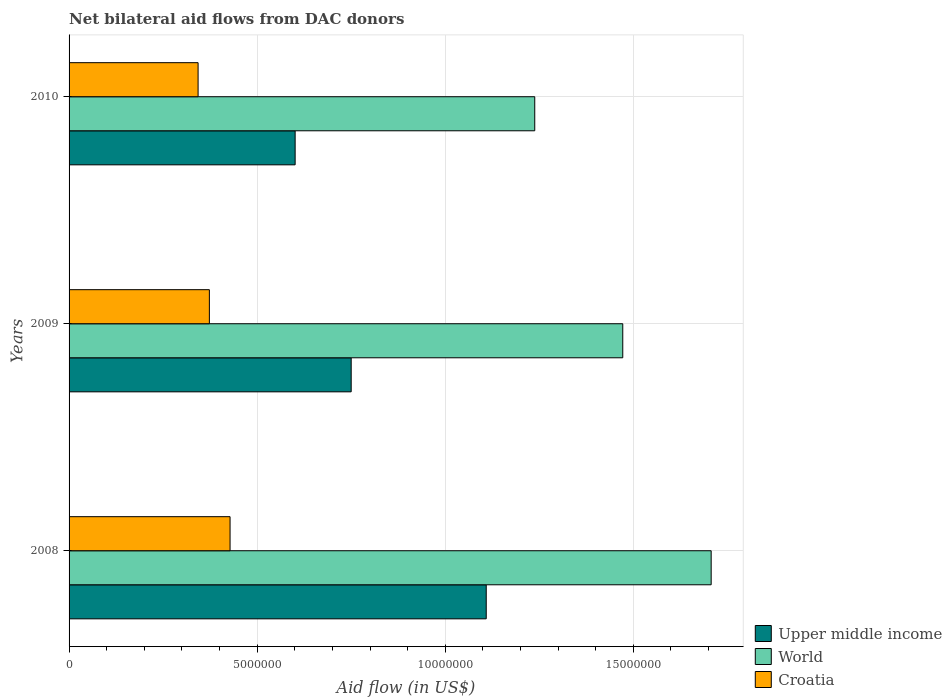Are the number of bars on each tick of the Y-axis equal?
Give a very brief answer. Yes. What is the label of the 2nd group of bars from the top?
Give a very brief answer. 2009. In how many cases, is the number of bars for a given year not equal to the number of legend labels?
Your response must be concise. 0. What is the net bilateral aid flow in Croatia in 2008?
Make the answer very short. 4.28e+06. Across all years, what is the maximum net bilateral aid flow in Croatia?
Offer a very short reply. 4.28e+06. Across all years, what is the minimum net bilateral aid flow in Croatia?
Offer a very short reply. 3.43e+06. In which year was the net bilateral aid flow in Croatia minimum?
Your answer should be very brief. 2010. What is the total net bilateral aid flow in World in the graph?
Provide a succinct answer. 4.42e+07. What is the difference between the net bilateral aid flow in Upper middle income in 2009 and that in 2010?
Your answer should be compact. 1.49e+06. What is the difference between the net bilateral aid flow in Upper middle income in 2009 and the net bilateral aid flow in Croatia in 2008?
Keep it short and to the point. 3.22e+06. What is the average net bilateral aid flow in World per year?
Your answer should be very brief. 1.47e+07. In the year 2010, what is the difference between the net bilateral aid flow in Upper middle income and net bilateral aid flow in Croatia?
Keep it short and to the point. 2.58e+06. In how many years, is the net bilateral aid flow in Upper middle income greater than 4000000 US$?
Your answer should be very brief. 3. What is the ratio of the net bilateral aid flow in Croatia in 2008 to that in 2009?
Make the answer very short. 1.15. Is the difference between the net bilateral aid flow in Upper middle income in 2008 and 2009 greater than the difference between the net bilateral aid flow in Croatia in 2008 and 2009?
Give a very brief answer. Yes. What is the difference between the highest and the second highest net bilateral aid flow in Croatia?
Your answer should be very brief. 5.50e+05. What is the difference between the highest and the lowest net bilateral aid flow in Upper middle income?
Provide a short and direct response. 5.08e+06. In how many years, is the net bilateral aid flow in Croatia greater than the average net bilateral aid flow in Croatia taken over all years?
Make the answer very short. 1. Is the sum of the net bilateral aid flow in Croatia in 2009 and 2010 greater than the maximum net bilateral aid flow in World across all years?
Provide a short and direct response. No. What does the 1st bar from the top in 2008 represents?
Make the answer very short. Croatia. Is it the case that in every year, the sum of the net bilateral aid flow in Upper middle income and net bilateral aid flow in World is greater than the net bilateral aid flow in Croatia?
Give a very brief answer. Yes. Are all the bars in the graph horizontal?
Your response must be concise. Yes. How many years are there in the graph?
Keep it short and to the point. 3. What is the difference between two consecutive major ticks on the X-axis?
Ensure brevity in your answer.  5.00e+06. Does the graph contain any zero values?
Your answer should be compact. No. Does the graph contain grids?
Provide a short and direct response. Yes. Where does the legend appear in the graph?
Provide a short and direct response. Bottom right. How are the legend labels stacked?
Provide a short and direct response. Vertical. What is the title of the graph?
Your answer should be compact. Net bilateral aid flows from DAC donors. Does "OECD members" appear as one of the legend labels in the graph?
Offer a terse response. No. What is the label or title of the X-axis?
Give a very brief answer. Aid flow (in US$). What is the Aid flow (in US$) of Upper middle income in 2008?
Keep it short and to the point. 1.11e+07. What is the Aid flow (in US$) in World in 2008?
Keep it short and to the point. 1.71e+07. What is the Aid flow (in US$) of Croatia in 2008?
Your answer should be compact. 4.28e+06. What is the Aid flow (in US$) in Upper middle income in 2009?
Offer a terse response. 7.50e+06. What is the Aid flow (in US$) in World in 2009?
Keep it short and to the point. 1.47e+07. What is the Aid flow (in US$) of Croatia in 2009?
Make the answer very short. 3.73e+06. What is the Aid flow (in US$) of Upper middle income in 2010?
Provide a short and direct response. 6.01e+06. What is the Aid flow (in US$) in World in 2010?
Your answer should be very brief. 1.24e+07. What is the Aid flow (in US$) in Croatia in 2010?
Provide a succinct answer. 3.43e+06. Across all years, what is the maximum Aid flow (in US$) in Upper middle income?
Offer a very short reply. 1.11e+07. Across all years, what is the maximum Aid flow (in US$) of World?
Keep it short and to the point. 1.71e+07. Across all years, what is the maximum Aid flow (in US$) of Croatia?
Provide a short and direct response. 4.28e+06. Across all years, what is the minimum Aid flow (in US$) of Upper middle income?
Your answer should be very brief. 6.01e+06. Across all years, what is the minimum Aid flow (in US$) of World?
Provide a succinct answer. 1.24e+07. Across all years, what is the minimum Aid flow (in US$) in Croatia?
Your answer should be compact. 3.43e+06. What is the total Aid flow (in US$) in Upper middle income in the graph?
Offer a very short reply. 2.46e+07. What is the total Aid flow (in US$) in World in the graph?
Give a very brief answer. 4.42e+07. What is the total Aid flow (in US$) of Croatia in the graph?
Your response must be concise. 1.14e+07. What is the difference between the Aid flow (in US$) of Upper middle income in 2008 and that in 2009?
Your answer should be very brief. 3.59e+06. What is the difference between the Aid flow (in US$) in World in 2008 and that in 2009?
Ensure brevity in your answer.  2.35e+06. What is the difference between the Aid flow (in US$) of Upper middle income in 2008 and that in 2010?
Keep it short and to the point. 5.08e+06. What is the difference between the Aid flow (in US$) of World in 2008 and that in 2010?
Make the answer very short. 4.69e+06. What is the difference between the Aid flow (in US$) of Croatia in 2008 and that in 2010?
Ensure brevity in your answer.  8.50e+05. What is the difference between the Aid flow (in US$) of Upper middle income in 2009 and that in 2010?
Provide a succinct answer. 1.49e+06. What is the difference between the Aid flow (in US$) in World in 2009 and that in 2010?
Provide a succinct answer. 2.34e+06. What is the difference between the Aid flow (in US$) of Croatia in 2009 and that in 2010?
Give a very brief answer. 3.00e+05. What is the difference between the Aid flow (in US$) of Upper middle income in 2008 and the Aid flow (in US$) of World in 2009?
Give a very brief answer. -3.63e+06. What is the difference between the Aid flow (in US$) in Upper middle income in 2008 and the Aid flow (in US$) in Croatia in 2009?
Offer a terse response. 7.36e+06. What is the difference between the Aid flow (in US$) in World in 2008 and the Aid flow (in US$) in Croatia in 2009?
Provide a succinct answer. 1.33e+07. What is the difference between the Aid flow (in US$) in Upper middle income in 2008 and the Aid flow (in US$) in World in 2010?
Provide a short and direct response. -1.29e+06. What is the difference between the Aid flow (in US$) in Upper middle income in 2008 and the Aid flow (in US$) in Croatia in 2010?
Provide a succinct answer. 7.66e+06. What is the difference between the Aid flow (in US$) in World in 2008 and the Aid flow (in US$) in Croatia in 2010?
Your response must be concise. 1.36e+07. What is the difference between the Aid flow (in US$) in Upper middle income in 2009 and the Aid flow (in US$) in World in 2010?
Your answer should be very brief. -4.88e+06. What is the difference between the Aid flow (in US$) of Upper middle income in 2009 and the Aid flow (in US$) of Croatia in 2010?
Provide a short and direct response. 4.07e+06. What is the difference between the Aid flow (in US$) in World in 2009 and the Aid flow (in US$) in Croatia in 2010?
Make the answer very short. 1.13e+07. What is the average Aid flow (in US$) of Upper middle income per year?
Provide a succinct answer. 8.20e+06. What is the average Aid flow (in US$) of World per year?
Make the answer very short. 1.47e+07. What is the average Aid flow (in US$) in Croatia per year?
Keep it short and to the point. 3.81e+06. In the year 2008, what is the difference between the Aid flow (in US$) of Upper middle income and Aid flow (in US$) of World?
Keep it short and to the point. -5.98e+06. In the year 2008, what is the difference between the Aid flow (in US$) in Upper middle income and Aid flow (in US$) in Croatia?
Make the answer very short. 6.81e+06. In the year 2008, what is the difference between the Aid flow (in US$) in World and Aid flow (in US$) in Croatia?
Your answer should be very brief. 1.28e+07. In the year 2009, what is the difference between the Aid flow (in US$) in Upper middle income and Aid flow (in US$) in World?
Offer a terse response. -7.22e+06. In the year 2009, what is the difference between the Aid flow (in US$) of Upper middle income and Aid flow (in US$) of Croatia?
Provide a succinct answer. 3.77e+06. In the year 2009, what is the difference between the Aid flow (in US$) of World and Aid flow (in US$) of Croatia?
Your answer should be very brief. 1.10e+07. In the year 2010, what is the difference between the Aid flow (in US$) of Upper middle income and Aid flow (in US$) of World?
Give a very brief answer. -6.37e+06. In the year 2010, what is the difference between the Aid flow (in US$) of Upper middle income and Aid flow (in US$) of Croatia?
Your answer should be compact. 2.58e+06. In the year 2010, what is the difference between the Aid flow (in US$) in World and Aid flow (in US$) in Croatia?
Your answer should be compact. 8.95e+06. What is the ratio of the Aid flow (in US$) of Upper middle income in 2008 to that in 2009?
Your answer should be very brief. 1.48. What is the ratio of the Aid flow (in US$) of World in 2008 to that in 2009?
Offer a very short reply. 1.16. What is the ratio of the Aid flow (in US$) in Croatia in 2008 to that in 2009?
Your answer should be compact. 1.15. What is the ratio of the Aid flow (in US$) of Upper middle income in 2008 to that in 2010?
Give a very brief answer. 1.85. What is the ratio of the Aid flow (in US$) of World in 2008 to that in 2010?
Ensure brevity in your answer.  1.38. What is the ratio of the Aid flow (in US$) of Croatia in 2008 to that in 2010?
Your answer should be compact. 1.25. What is the ratio of the Aid flow (in US$) in Upper middle income in 2009 to that in 2010?
Provide a short and direct response. 1.25. What is the ratio of the Aid flow (in US$) of World in 2009 to that in 2010?
Give a very brief answer. 1.19. What is the ratio of the Aid flow (in US$) in Croatia in 2009 to that in 2010?
Provide a succinct answer. 1.09. What is the difference between the highest and the second highest Aid flow (in US$) in Upper middle income?
Your answer should be compact. 3.59e+06. What is the difference between the highest and the second highest Aid flow (in US$) in World?
Make the answer very short. 2.35e+06. What is the difference between the highest and the lowest Aid flow (in US$) in Upper middle income?
Your response must be concise. 5.08e+06. What is the difference between the highest and the lowest Aid flow (in US$) of World?
Offer a terse response. 4.69e+06. What is the difference between the highest and the lowest Aid flow (in US$) in Croatia?
Your response must be concise. 8.50e+05. 